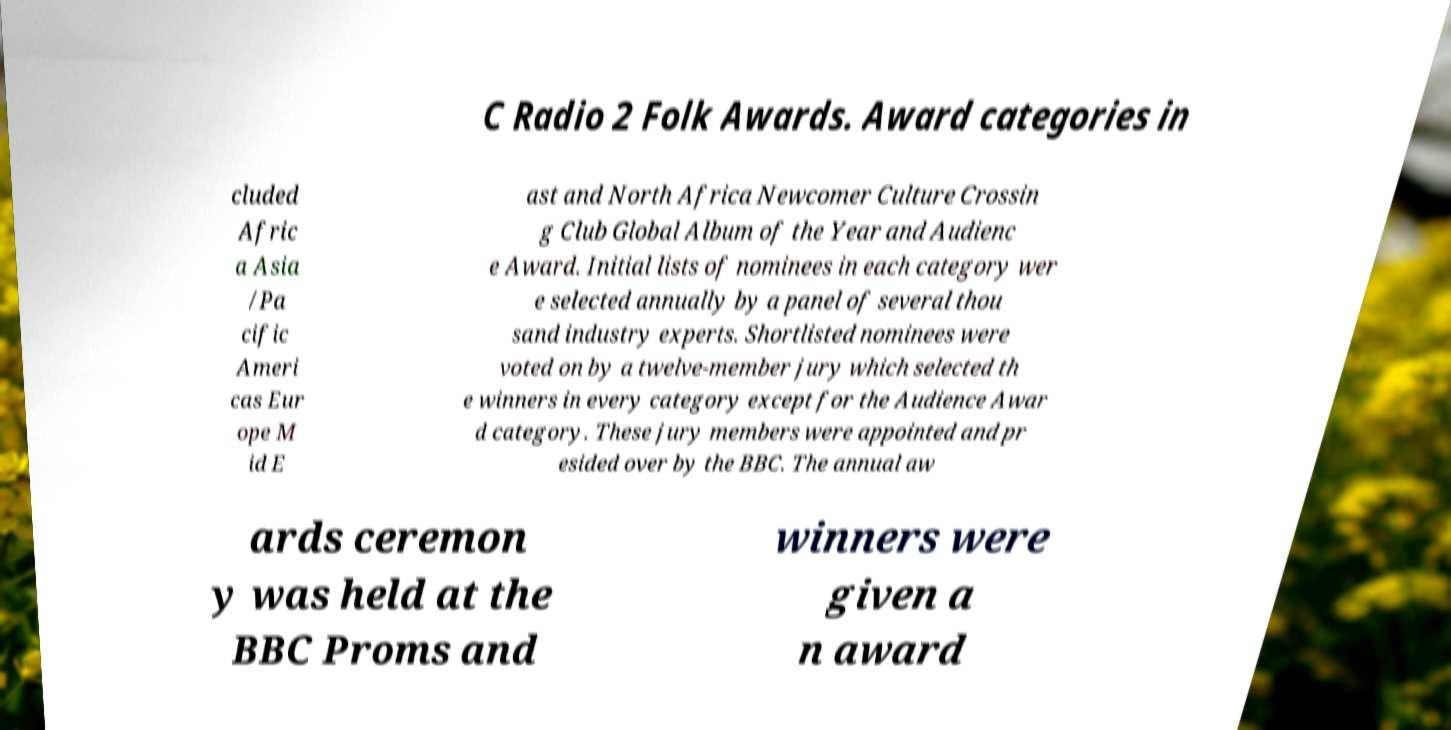Please read and relay the text visible in this image. What does it say? C Radio 2 Folk Awards. Award categories in cluded Afric a Asia /Pa cific Ameri cas Eur ope M id E ast and North Africa Newcomer Culture Crossin g Club Global Album of the Year and Audienc e Award. Initial lists of nominees in each category wer e selected annually by a panel of several thou sand industry experts. Shortlisted nominees were voted on by a twelve-member jury which selected th e winners in every category except for the Audience Awar d category. These jury members were appointed and pr esided over by the BBC. The annual aw ards ceremon y was held at the BBC Proms and winners were given a n award 